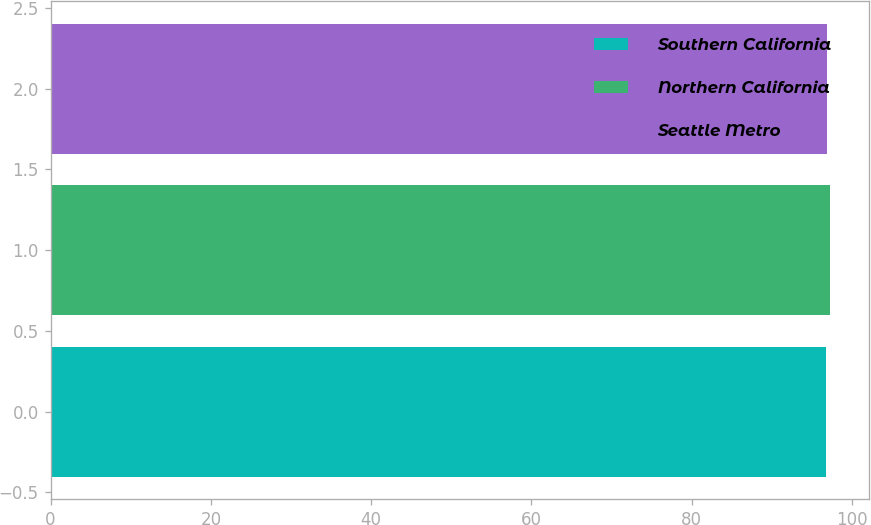<chart> <loc_0><loc_0><loc_500><loc_500><bar_chart><fcel>Southern California<fcel>Northern California<fcel>Seattle Metro<nl><fcel>96.8<fcel>97.2<fcel>96.9<nl></chart> 